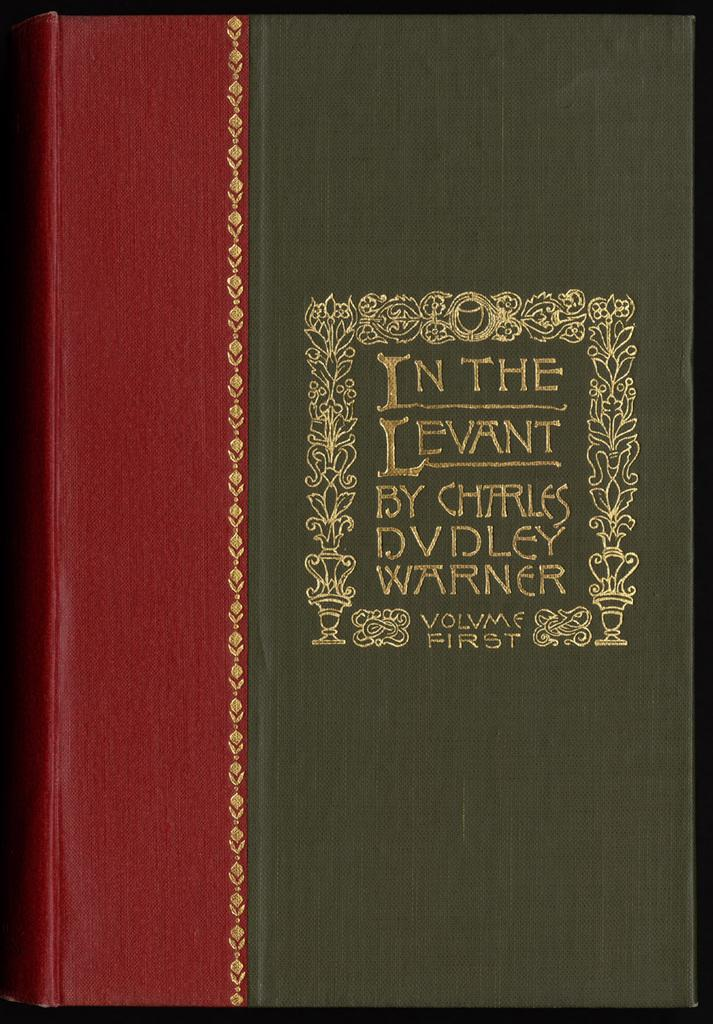Provide a one-sentence caption for the provided image. The front of the book reads In the Levant. 